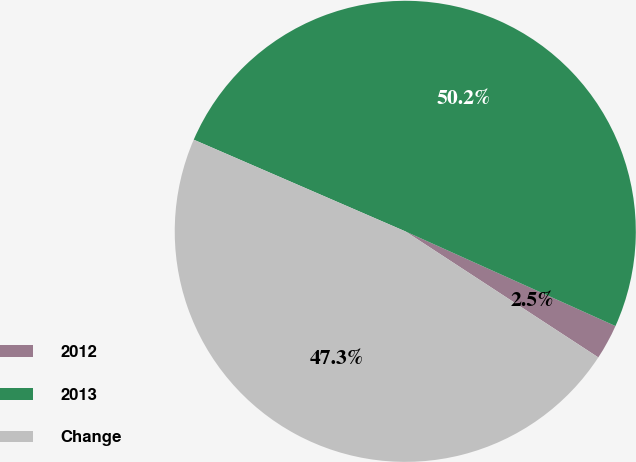Convert chart to OTSL. <chart><loc_0><loc_0><loc_500><loc_500><pie_chart><fcel>2012<fcel>2013<fcel>Change<nl><fcel>2.47%<fcel>50.23%<fcel>47.3%<nl></chart> 